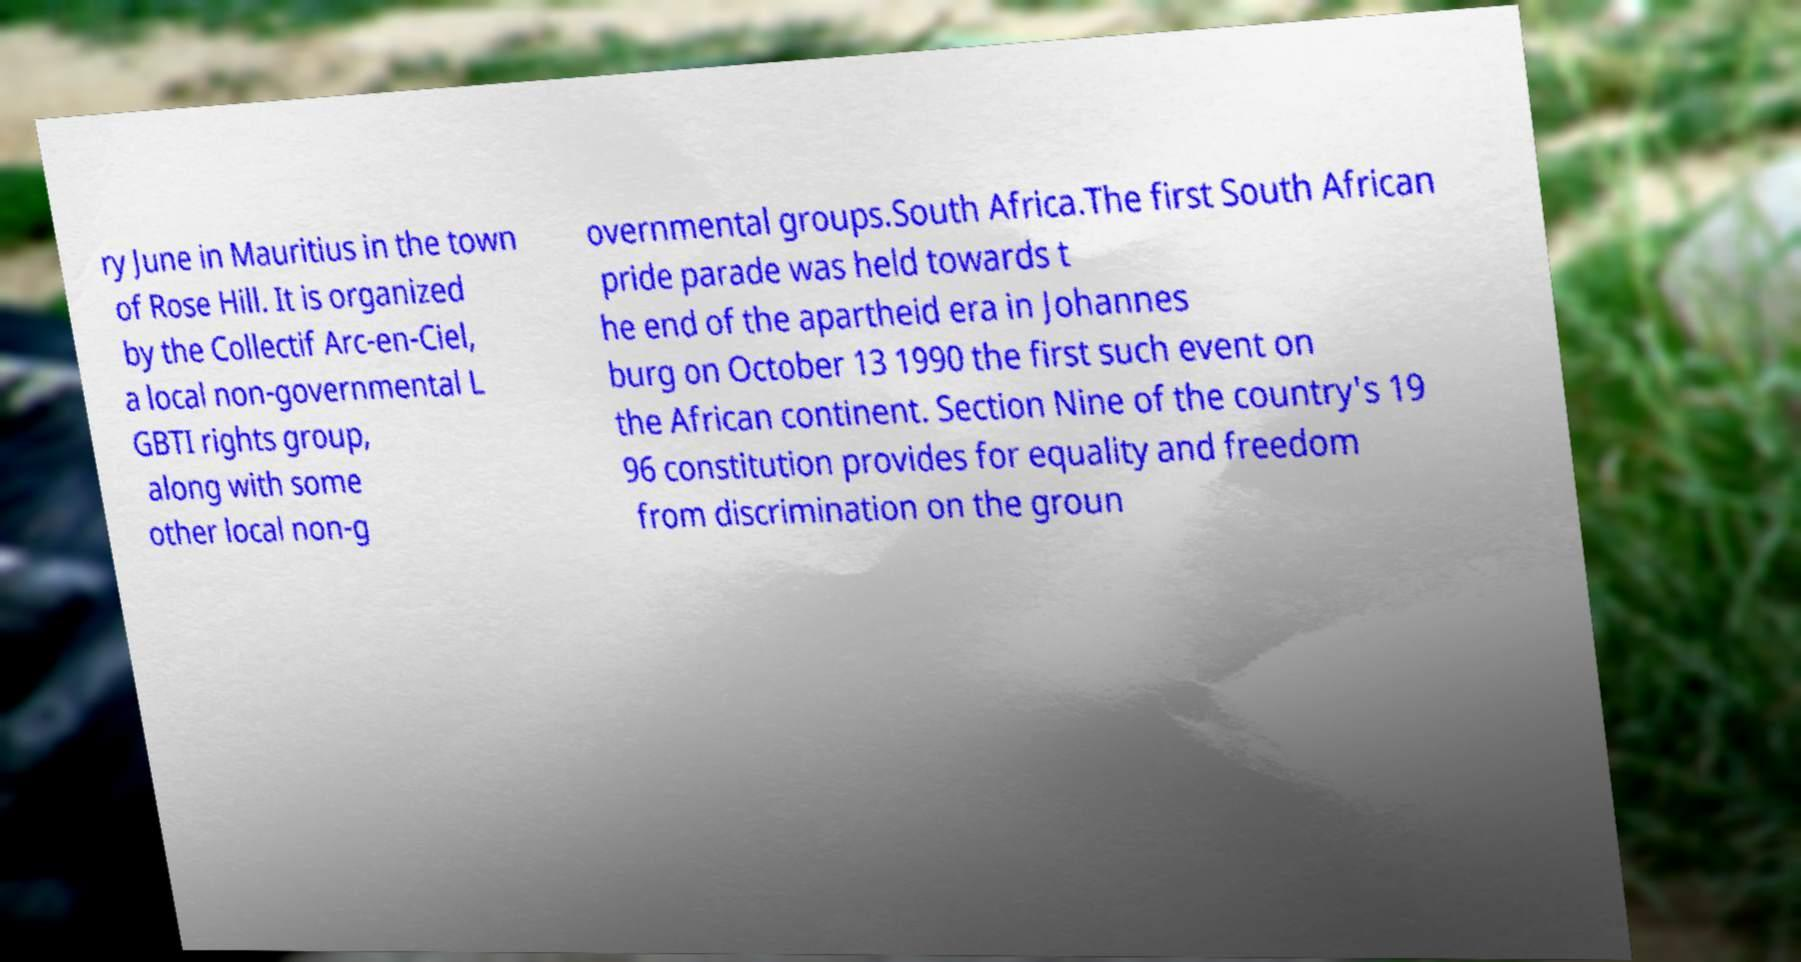Can you read and provide the text displayed in the image?This photo seems to have some interesting text. Can you extract and type it out for me? ry June in Mauritius in the town of Rose Hill. It is organized by the Collectif Arc-en-Ciel, a local non-governmental L GBTI rights group, along with some other local non-g overnmental groups.South Africa.The first South African pride parade was held towards t he end of the apartheid era in Johannes burg on October 13 1990 the first such event on the African continent. Section Nine of the country's 19 96 constitution provides for equality and freedom from discrimination on the groun 